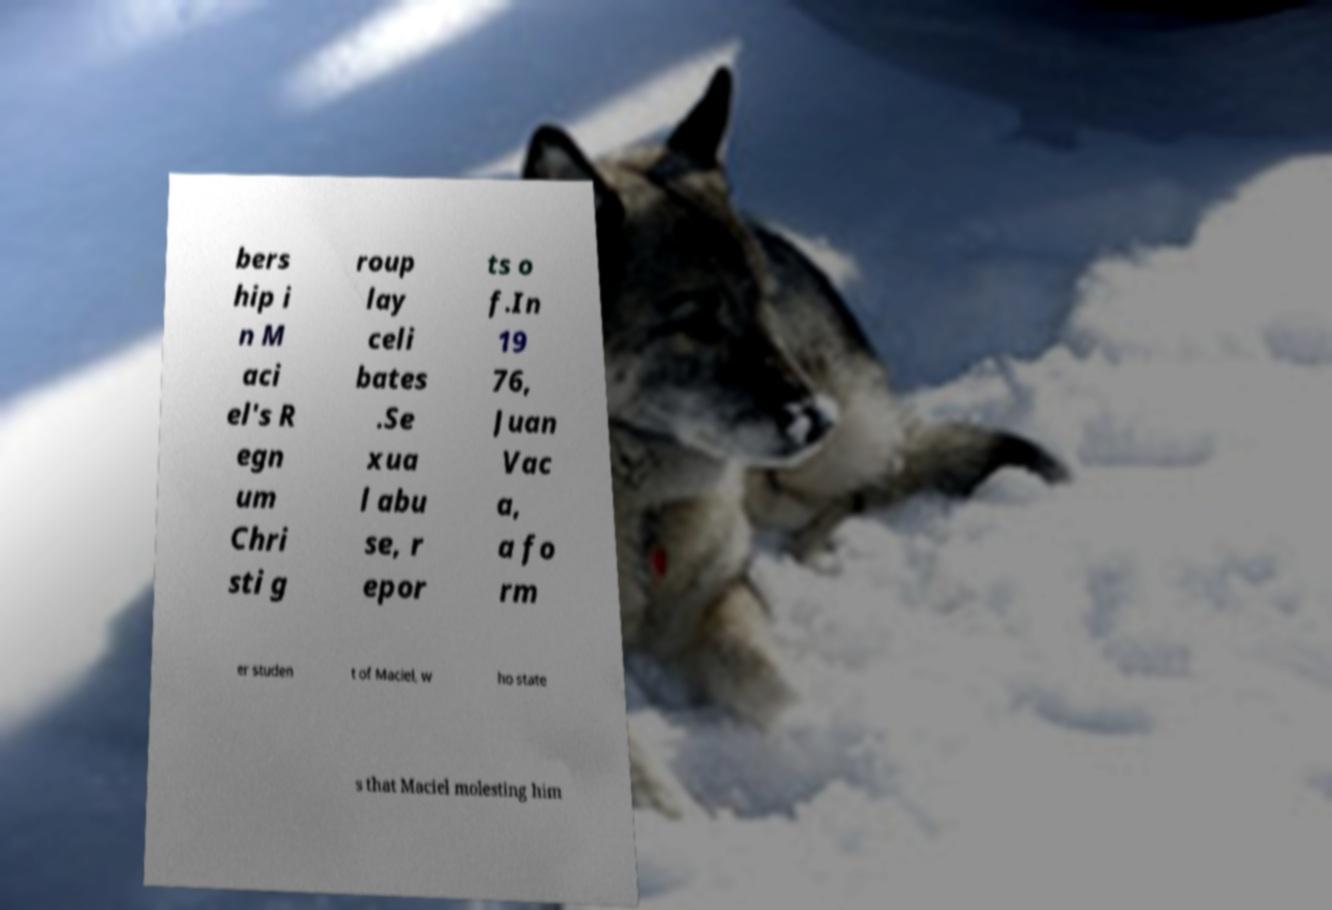What messages or text are displayed in this image? I need them in a readable, typed format. bers hip i n M aci el's R egn um Chri sti g roup lay celi bates .Se xua l abu se, r epor ts o f.In 19 76, Juan Vac a, a fo rm er studen t of Maciel, w ho state s that Maciel molesting him 